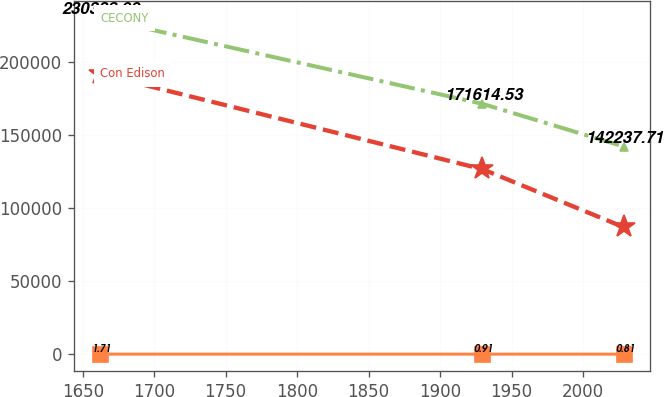<chart> <loc_0><loc_0><loc_500><loc_500><line_chart><ecel><fcel>Unnamed: 1<fcel>CECONY<fcel>Con Edison<nl><fcel>1662.09<fcel>1.71<fcel>230329<fcel>192134<nl><fcel>1929.61<fcel>0.91<fcel>171615<fcel>126816<nl><fcel>2028.81<fcel>0.81<fcel>142238<fcel>86913<nl></chart> 